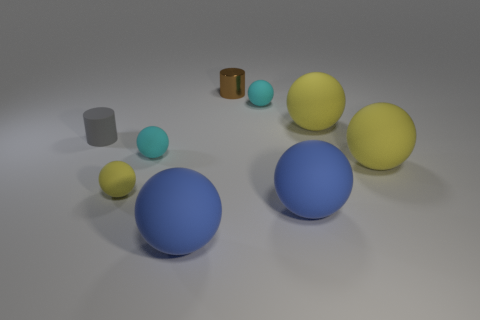Can you describe the lighting and shadows in the scene? The lighting in the scene appears to be coming from above, casting soft shadows directly beneath the objects, suggesting a single diffuse light source somewhere above the center of the arrangement. 